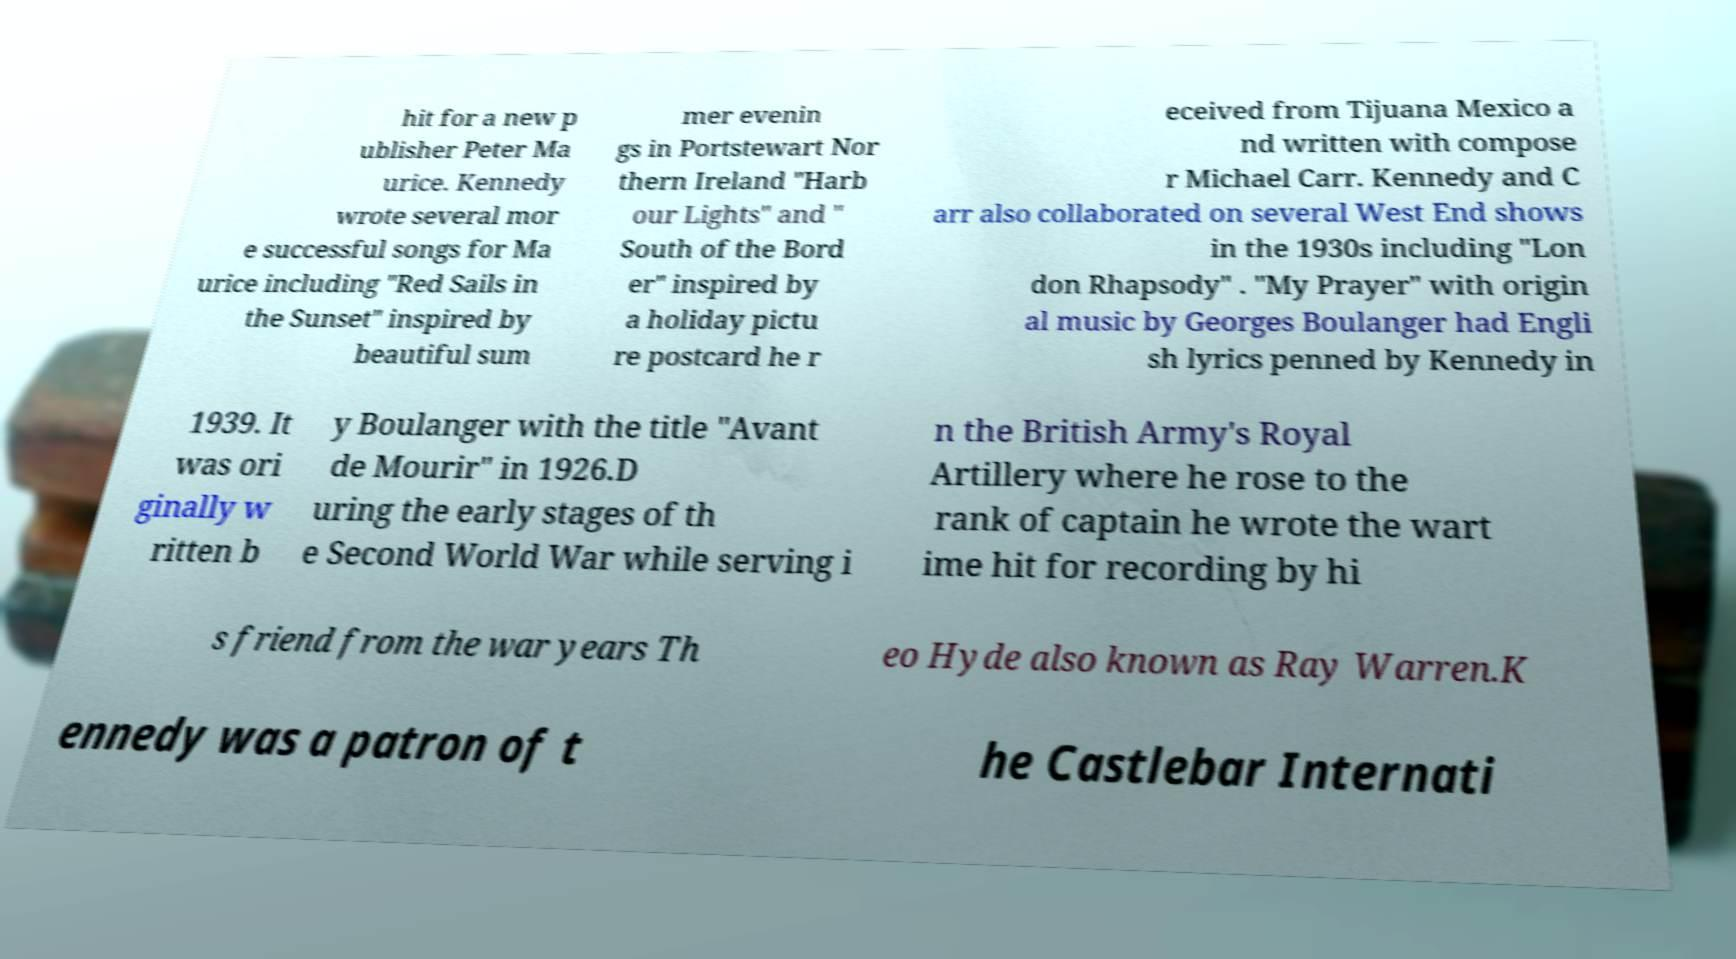Can you read and provide the text displayed in the image?This photo seems to have some interesting text. Can you extract and type it out for me? hit for a new p ublisher Peter Ma urice. Kennedy wrote several mor e successful songs for Ma urice including "Red Sails in the Sunset" inspired by beautiful sum mer evenin gs in Portstewart Nor thern Ireland "Harb our Lights" and " South of the Bord er" inspired by a holiday pictu re postcard he r eceived from Tijuana Mexico a nd written with compose r Michael Carr. Kennedy and C arr also collaborated on several West End shows in the 1930s including "Lon don Rhapsody" . "My Prayer" with origin al music by Georges Boulanger had Engli sh lyrics penned by Kennedy in 1939. It was ori ginally w ritten b y Boulanger with the title "Avant de Mourir" in 1926.D uring the early stages of th e Second World War while serving i n the British Army's Royal Artillery where he rose to the rank of captain he wrote the wart ime hit for recording by hi s friend from the war years Th eo Hyde also known as Ray Warren.K ennedy was a patron of t he Castlebar Internati 